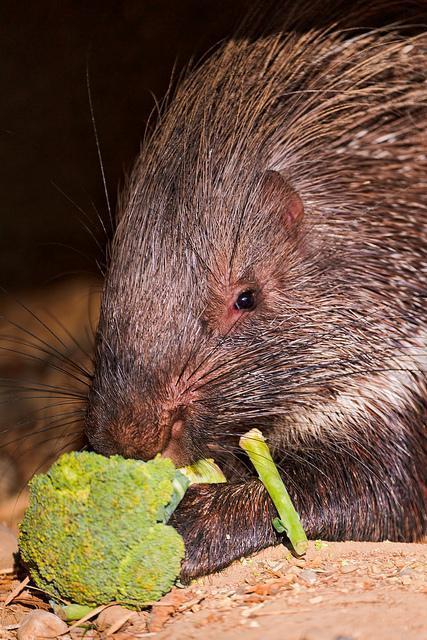How many birds are there?
Give a very brief answer. 0. 